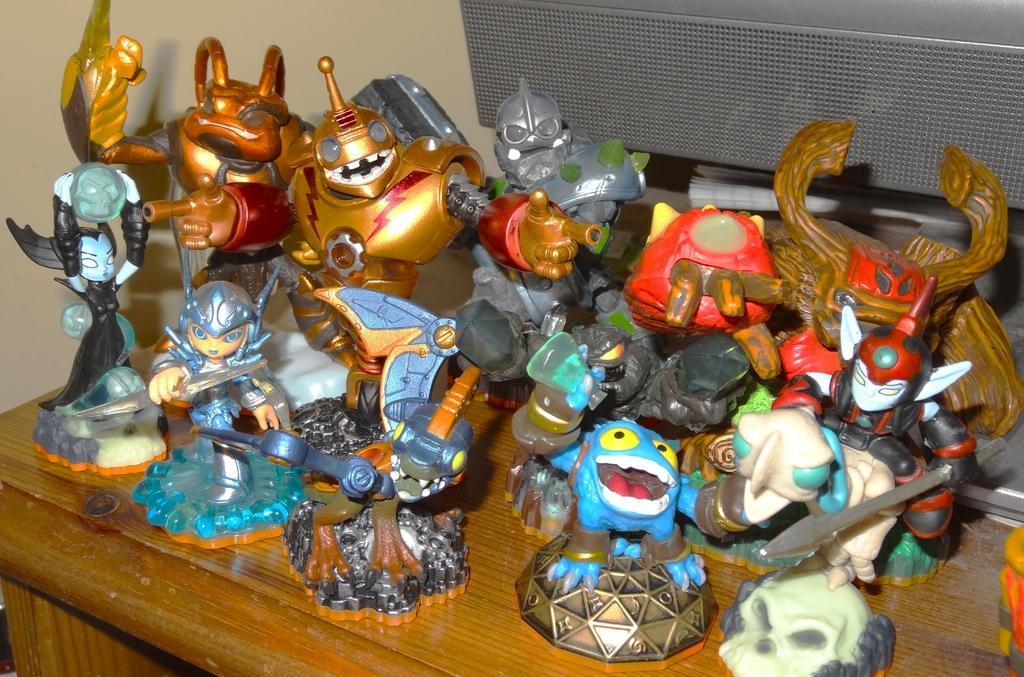Describe this image in one or two sentences. At the bottom of the image there is a table. On the table there are many toys. Behind them there is a book and an object. 